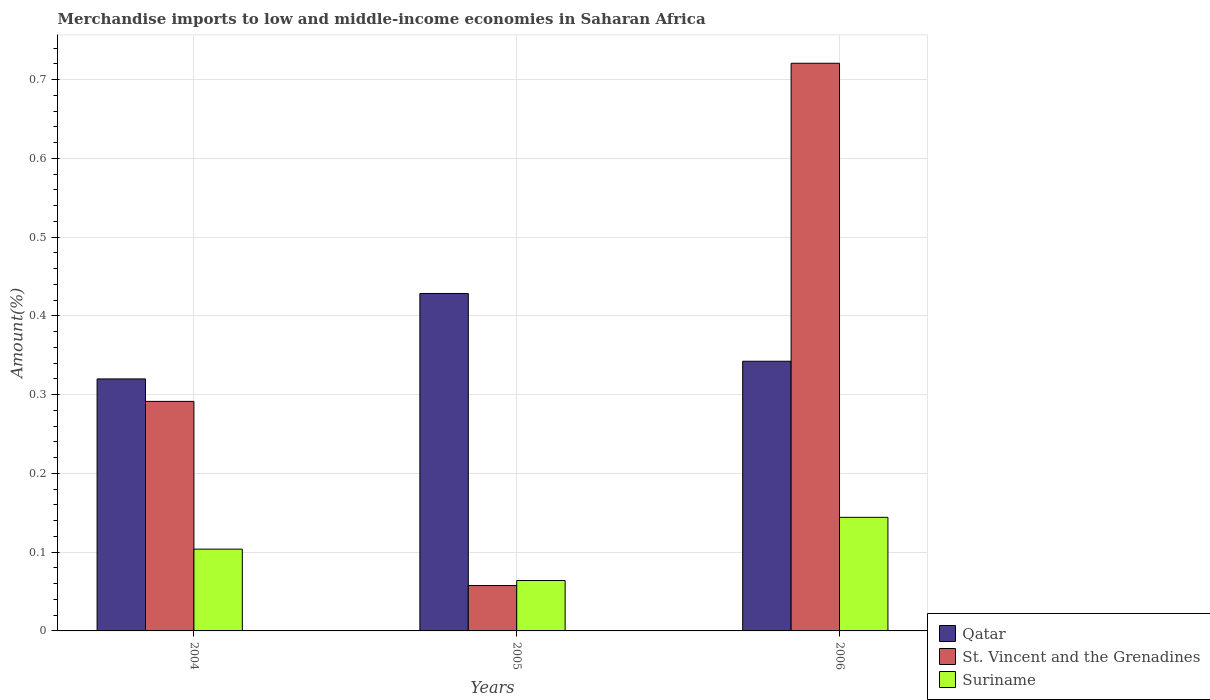How many different coloured bars are there?
Provide a succinct answer. 3. How many groups of bars are there?
Provide a short and direct response. 3. Are the number of bars per tick equal to the number of legend labels?
Your answer should be compact. Yes. Are the number of bars on each tick of the X-axis equal?
Make the answer very short. Yes. How many bars are there on the 3rd tick from the left?
Provide a short and direct response. 3. How many bars are there on the 2nd tick from the right?
Keep it short and to the point. 3. What is the percentage of amount earned from merchandise imports in St. Vincent and the Grenadines in 2004?
Your answer should be very brief. 0.29. Across all years, what is the maximum percentage of amount earned from merchandise imports in St. Vincent and the Grenadines?
Provide a short and direct response. 0.72. Across all years, what is the minimum percentage of amount earned from merchandise imports in Suriname?
Your answer should be compact. 0.06. In which year was the percentage of amount earned from merchandise imports in Suriname maximum?
Make the answer very short. 2006. In which year was the percentage of amount earned from merchandise imports in Suriname minimum?
Keep it short and to the point. 2005. What is the total percentage of amount earned from merchandise imports in Suriname in the graph?
Make the answer very short. 0.31. What is the difference between the percentage of amount earned from merchandise imports in Qatar in 2005 and that in 2006?
Provide a succinct answer. 0.09. What is the difference between the percentage of amount earned from merchandise imports in Suriname in 2005 and the percentage of amount earned from merchandise imports in St. Vincent and the Grenadines in 2004?
Keep it short and to the point. -0.23. What is the average percentage of amount earned from merchandise imports in Qatar per year?
Give a very brief answer. 0.36. In the year 2006, what is the difference between the percentage of amount earned from merchandise imports in Qatar and percentage of amount earned from merchandise imports in St. Vincent and the Grenadines?
Keep it short and to the point. -0.38. In how many years, is the percentage of amount earned from merchandise imports in Suriname greater than 0.7000000000000001 %?
Ensure brevity in your answer.  0. What is the ratio of the percentage of amount earned from merchandise imports in St. Vincent and the Grenadines in 2004 to that in 2005?
Your answer should be compact. 5.06. What is the difference between the highest and the second highest percentage of amount earned from merchandise imports in Suriname?
Your answer should be compact. 0.04. What is the difference between the highest and the lowest percentage of amount earned from merchandise imports in St. Vincent and the Grenadines?
Give a very brief answer. 0.66. In how many years, is the percentage of amount earned from merchandise imports in Qatar greater than the average percentage of amount earned from merchandise imports in Qatar taken over all years?
Give a very brief answer. 1. Is the sum of the percentage of amount earned from merchandise imports in St. Vincent and the Grenadines in 2004 and 2005 greater than the maximum percentage of amount earned from merchandise imports in Suriname across all years?
Provide a short and direct response. Yes. What does the 1st bar from the left in 2005 represents?
Your response must be concise. Qatar. What does the 3rd bar from the right in 2005 represents?
Make the answer very short. Qatar. How many years are there in the graph?
Provide a short and direct response. 3. Does the graph contain any zero values?
Provide a succinct answer. No. How many legend labels are there?
Make the answer very short. 3. How are the legend labels stacked?
Give a very brief answer. Vertical. What is the title of the graph?
Give a very brief answer. Merchandise imports to low and middle-income economies in Saharan Africa. What is the label or title of the X-axis?
Provide a succinct answer. Years. What is the label or title of the Y-axis?
Make the answer very short. Amount(%). What is the Amount(%) in Qatar in 2004?
Keep it short and to the point. 0.32. What is the Amount(%) in St. Vincent and the Grenadines in 2004?
Offer a very short reply. 0.29. What is the Amount(%) in Suriname in 2004?
Make the answer very short. 0.1. What is the Amount(%) of Qatar in 2005?
Give a very brief answer. 0.43. What is the Amount(%) of St. Vincent and the Grenadines in 2005?
Give a very brief answer. 0.06. What is the Amount(%) of Suriname in 2005?
Provide a succinct answer. 0.06. What is the Amount(%) of Qatar in 2006?
Provide a succinct answer. 0.34. What is the Amount(%) in St. Vincent and the Grenadines in 2006?
Your answer should be compact. 0.72. What is the Amount(%) in Suriname in 2006?
Give a very brief answer. 0.14. Across all years, what is the maximum Amount(%) in Qatar?
Make the answer very short. 0.43. Across all years, what is the maximum Amount(%) of St. Vincent and the Grenadines?
Offer a very short reply. 0.72. Across all years, what is the maximum Amount(%) of Suriname?
Keep it short and to the point. 0.14. Across all years, what is the minimum Amount(%) of Qatar?
Keep it short and to the point. 0.32. Across all years, what is the minimum Amount(%) in St. Vincent and the Grenadines?
Provide a succinct answer. 0.06. Across all years, what is the minimum Amount(%) of Suriname?
Keep it short and to the point. 0.06. What is the total Amount(%) of St. Vincent and the Grenadines in the graph?
Offer a very short reply. 1.07. What is the total Amount(%) of Suriname in the graph?
Your response must be concise. 0.31. What is the difference between the Amount(%) in Qatar in 2004 and that in 2005?
Keep it short and to the point. -0.11. What is the difference between the Amount(%) in St. Vincent and the Grenadines in 2004 and that in 2005?
Your answer should be very brief. 0.23. What is the difference between the Amount(%) of Suriname in 2004 and that in 2005?
Give a very brief answer. 0.04. What is the difference between the Amount(%) of Qatar in 2004 and that in 2006?
Your answer should be compact. -0.02. What is the difference between the Amount(%) of St. Vincent and the Grenadines in 2004 and that in 2006?
Give a very brief answer. -0.43. What is the difference between the Amount(%) in Suriname in 2004 and that in 2006?
Offer a terse response. -0.04. What is the difference between the Amount(%) of Qatar in 2005 and that in 2006?
Ensure brevity in your answer.  0.09. What is the difference between the Amount(%) of St. Vincent and the Grenadines in 2005 and that in 2006?
Offer a very short reply. -0.66. What is the difference between the Amount(%) in Suriname in 2005 and that in 2006?
Ensure brevity in your answer.  -0.08. What is the difference between the Amount(%) of Qatar in 2004 and the Amount(%) of St. Vincent and the Grenadines in 2005?
Offer a very short reply. 0.26. What is the difference between the Amount(%) in Qatar in 2004 and the Amount(%) in Suriname in 2005?
Provide a short and direct response. 0.26. What is the difference between the Amount(%) in St. Vincent and the Grenadines in 2004 and the Amount(%) in Suriname in 2005?
Offer a very short reply. 0.23. What is the difference between the Amount(%) in Qatar in 2004 and the Amount(%) in St. Vincent and the Grenadines in 2006?
Ensure brevity in your answer.  -0.4. What is the difference between the Amount(%) in Qatar in 2004 and the Amount(%) in Suriname in 2006?
Make the answer very short. 0.18. What is the difference between the Amount(%) in St. Vincent and the Grenadines in 2004 and the Amount(%) in Suriname in 2006?
Offer a very short reply. 0.15. What is the difference between the Amount(%) of Qatar in 2005 and the Amount(%) of St. Vincent and the Grenadines in 2006?
Keep it short and to the point. -0.29. What is the difference between the Amount(%) of Qatar in 2005 and the Amount(%) of Suriname in 2006?
Offer a terse response. 0.28. What is the difference between the Amount(%) in St. Vincent and the Grenadines in 2005 and the Amount(%) in Suriname in 2006?
Offer a very short reply. -0.09. What is the average Amount(%) of Qatar per year?
Ensure brevity in your answer.  0.36. What is the average Amount(%) in St. Vincent and the Grenadines per year?
Offer a very short reply. 0.36. What is the average Amount(%) in Suriname per year?
Make the answer very short. 0.1. In the year 2004, what is the difference between the Amount(%) in Qatar and Amount(%) in St. Vincent and the Grenadines?
Your answer should be compact. 0.03. In the year 2004, what is the difference between the Amount(%) in Qatar and Amount(%) in Suriname?
Provide a succinct answer. 0.22. In the year 2004, what is the difference between the Amount(%) of St. Vincent and the Grenadines and Amount(%) of Suriname?
Ensure brevity in your answer.  0.19. In the year 2005, what is the difference between the Amount(%) in Qatar and Amount(%) in St. Vincent and the Grenadines?
Provide a succinct answer. 0.37. In the year 2005, what is the difference between the Amount(%) of Qatar and Amount(%) of Suriname?
Give a very brief answer. 0.36. In the year 2005, what is the difference between the Amount(%) of St. Vincent and the Grenadines and Amount(%) of Suriname?
Give a very brief answer. -0.01. In the year 2006, what is the difference between the Amount(%) in Qatar and Amount(%) in St. Vincent and the Grenadines?
Offer a very short reply. -0.38. In the year 2006, what is the difference between the Amount(%) in Qatar and Amount(%) in Suriname?
Ensure brevity in your answer.  0.2. In the year 2006, what is the difference between the Amount(%) of St. Vincent and the Grenadines and Amount(%) of Suriname?
Keep it short and to the point. 0.58. What is the ratio of the Amount(%) in Qatar in 2004 to that in 2005?
Provide a short and direct response. 0.75. What is the ratio of the Amount(%) of St. Vincent and the Grenadines in 2004 to that in 2005?
Offer a very short reply. 5.06. What is the ratio of the Amount(%) of Suriname in 2004 to that in 2005?
Keep it short and to the point. 1.62. What is the ratio of the Amount(%) in Qatar in 2004 to that in 2006?
Ensure brevity in your answer.  0.93. What is the ratio of the Amount(%) of St. Vincent and the Grenadines in 2004 to that in 2006?
Provide a short and direct response. 0.4. What is the ratio of the Amount(%) of Suriname in 2004 to that in 2006?
Provide a short and direct response. 0.72. What is the ratio of the Amount(%) in Qatar in 2005 to that in 2006?
Make the answer very short. 1.25. What is the ratio of the Amount(%) in St. Vincent and the Grenadines in 2005 to that in 2006?
Provide a succinct answer. 0.08. What is the ratio of the Amount(%) of Suriname in 2005 to that in 2006?
Make the answer very short. 0.44. What is the difference between the highest and the second highest Amount(%) of Qatar?
Give a very brief answer. 0.09. What is the difference between the highest and the second highest Amount(%) of St. Vincent and the Grenadines?
Keep it short and to the point. 0.43. What is the difference between the highest and the second highest Amount(%) of Suriname?
Provide a short and direct response. 0.04. What is the difference between the highest and the lowest Amount(%) of Qatar?
Your response must be concise. 0.11. What is the difference between the highest and the lowest Amount(%) in St. Vincent and the Grenadines?
Keep it short and to the point. 0.66. What is the difference between the highest and the lowest Amount(%) of Suriname?
Provide a succinct answer. 0.08. 